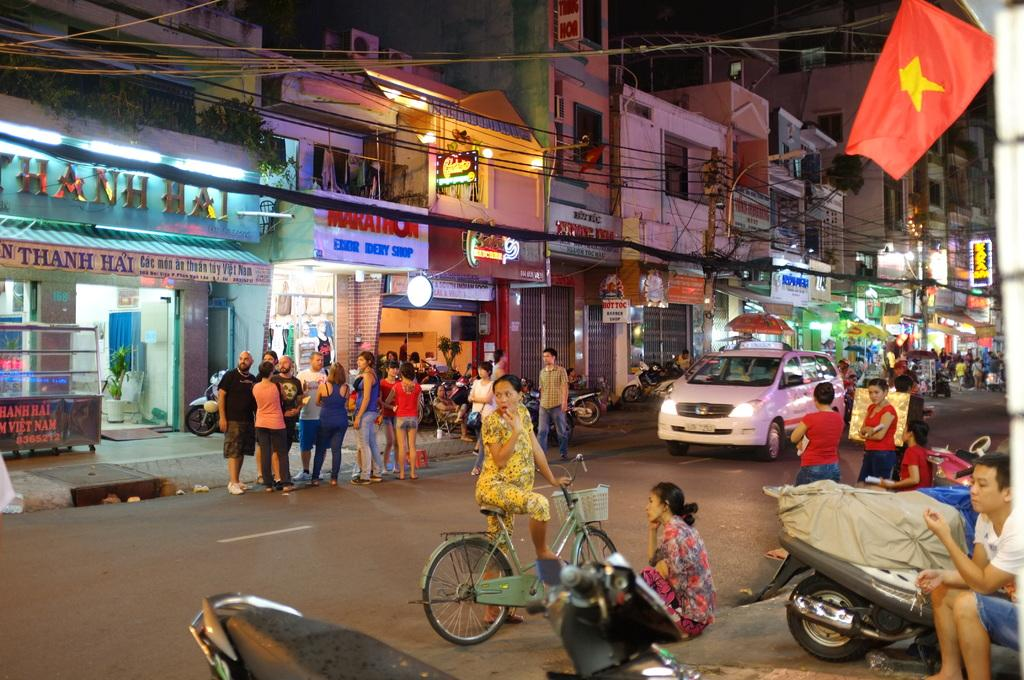<image>
Offer a succinct explanation of the picture presented. One of the businesses on the busy street is Marathon. 